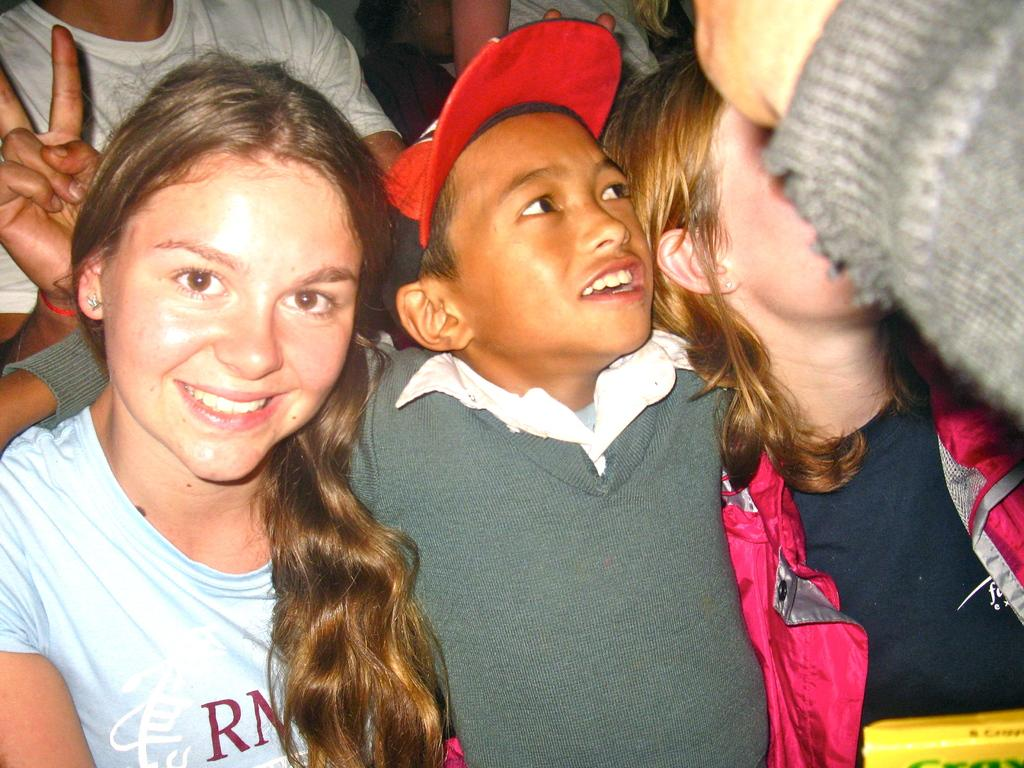How many children are in the image? The number of children in the image cannot be determined from the provided fact. What are the children doing in the image? The activity of the children in the image cannot be determined from the provided fact. Are the children alone in the image? The presence of other individuals in the image cannot be determined from the provided fact. What type of downtown area is visible in the image? There is no downtown area present in the image, as the provided fact only mentions the presence of children. What is being served for dinner in the image? There is no dinner present in the image, as the provided fact only mentions the presence of children. 